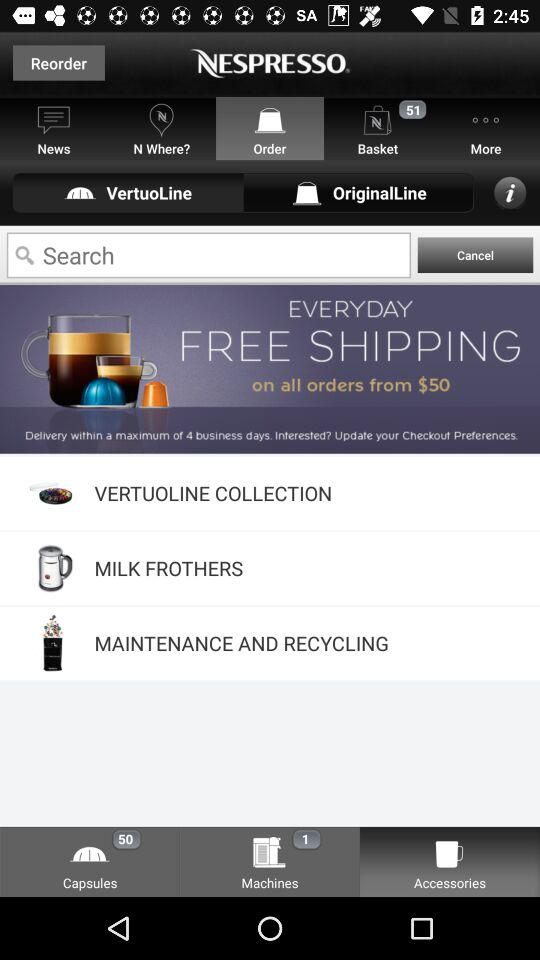What are the total number of baskets mentioned? The total number of baskets is 51. 